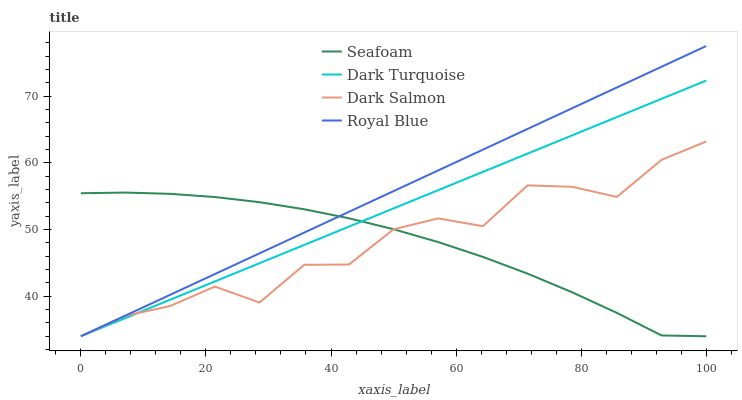Does Seafoam have the minimum area under the curve?
Answer yes or no. Yes. Does Royal Blue have the maximum area under the curve?
Answer yes or no. Yes. Does Royal Blue have the minimum area under the curve?
Answer yes or no. No. Does Seafoam have the maximum area under the curve?
Answer yes or no. No. Is Dark Turquoise the smoothest?
Answer yes or no. Yes. Is Dark Salmon the roughest?
Answer yes or no. Yes. Is Seafoam the smoothest?
Answer yes or no. No. Is Seafoam the roughest?
Answer yes or no. No. Does Dark Turquoise have the lowest value?
Answer yes or no. Yes. Does Royal Blue have the highest value?
Answer yes or no. Yes. Does Seafoam have the highest value?
Answer yes or no. No. Does Royal Blue intersect Seafoam?
Answer yes or no. Yes. Is Royal Blue less than Seafoam?
Answer yes or no. No. Is Royal Blue greater than Seafoam?
Answer yes or no. No. 